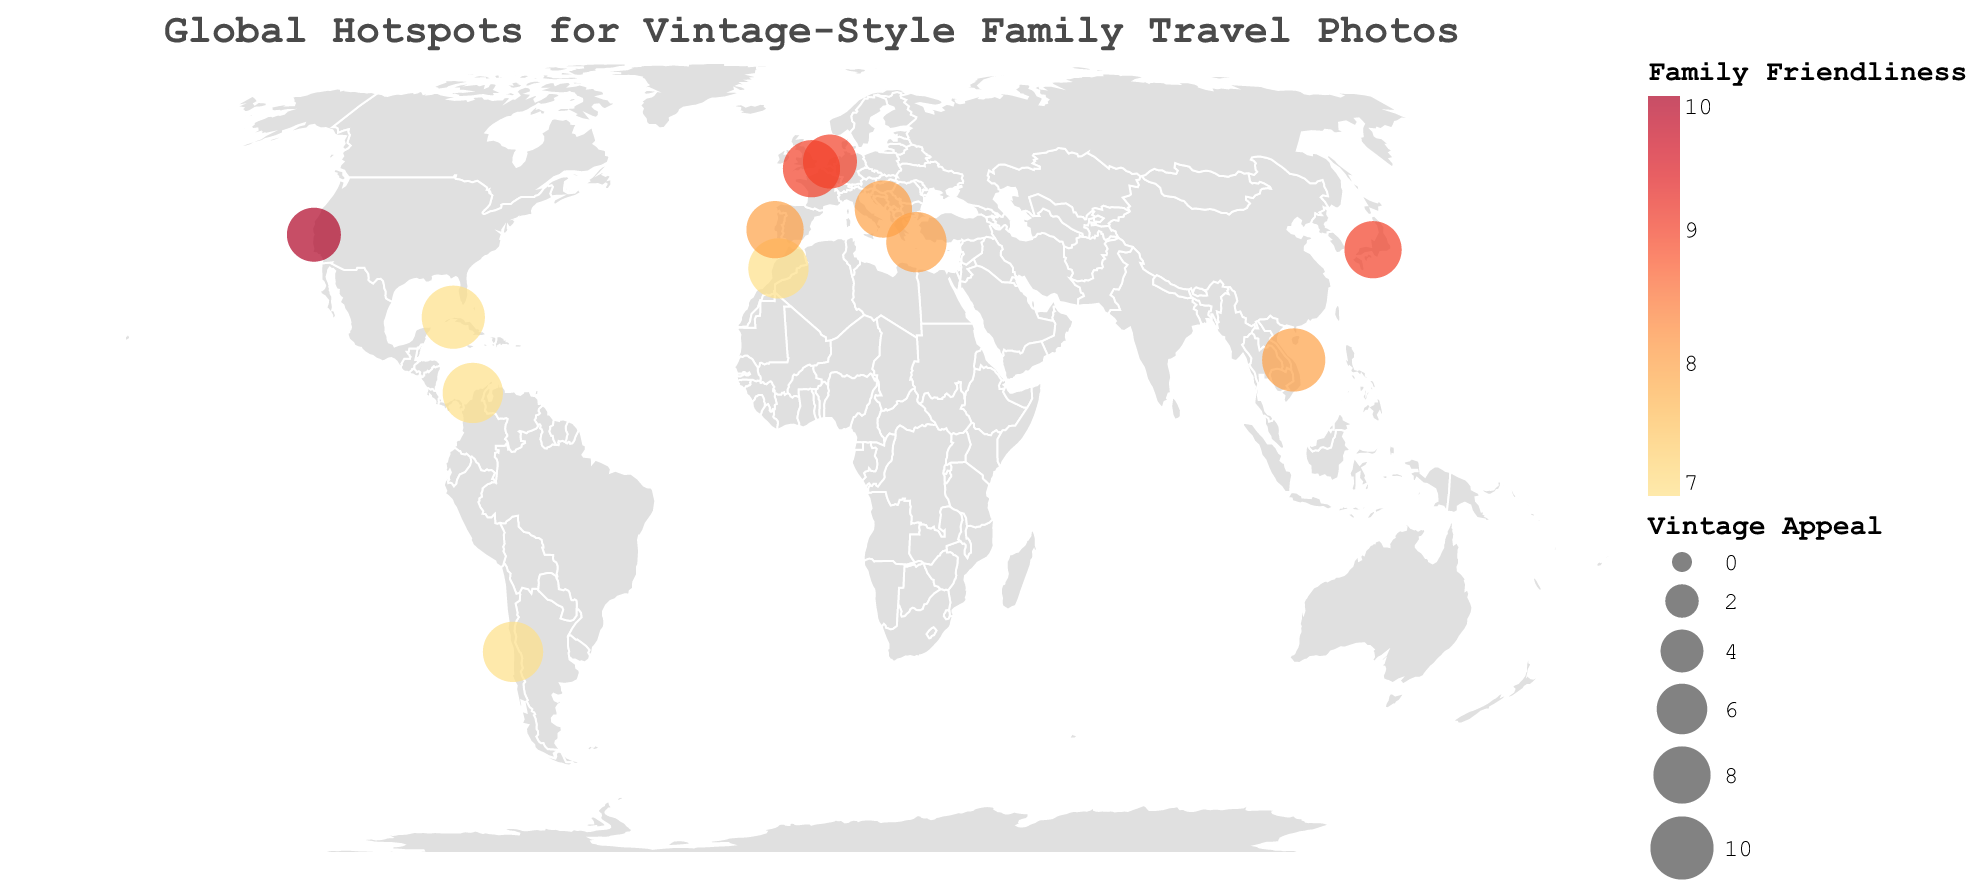What is the title of the figure? The title is prominently displayed at the top of the figure and typically provides a summary of the data being visualized.
Answer: Global Hotspots for Vintage-Style Family Travel Photos How many locations are plotted on the map? By counting the total number of circles (each representing a location), we can determine the number of plotted locations.
Answer: 12 Which location has the highest Vintage Appeal? We need to identify which circle represents the location with the largest size, as size is encoded for Vintage Appeal.
Answer: Havana, Cuba (Vintage Appeal: 10) Which location is the most family-friendly? By examining the color legend for Family Friendliness and finding the brightest circle, which corresponds to the highest value, we can determine this.
Answer: San Francisco, USA (Family Friendliness: 10) Which locations have a Vintage Appeal of 9? We need to identify all circles with a size corresponding to a Vintage Appeal of 9.
Answer: Santorini Greece, Marrakech Morocco, Cartagena Colombia, Valparaiso Chile How does the Vintage Appeal of Hoi An, Vietnam compare to Valparaiso, Chile? By comparing the sizes of the circles representing Hoi An and Valparaiso, we can determine how their Vintage Appeals relate to each other.
Answer: Hoi An, Vietnam has a higher Vintage Appeal than Valparaiso, Chile (10 vs 9) Which location appears to be the most balanced in terms of Vintage Appeal and Family Friendliness? By looking for circles where both the size and color indicate high values, we can determine the most balanced location.
Answer: Kyoto, Japan (Vintage Appeal: 8, Family Friendliness: 9) What is the average Family Friendliness of all the locations? We sum up the Family Friendliness scores for all locations and divide by the number of locations. (8 + 7 + 9 + 7 + 9 + 10 + 8 + 7 + 8 + 7 + 9 + 8) / 12 = 8
Answer: 8 In which region of the world is the majority of the high Vintage Appeal locations clustered? By observing the map and identifying the concentration of larger circles, we can determine the regional clustering.
Answer: Europe How does the Family Friendliness of Amsterdam, Netherlands compare to that of Brighton, UK? By examining and comparing the color brightness of the circles representing these two locations, we can determine the relationship.
Answer: Amsterdam and Brighton have the same Family Friendliness (9) 